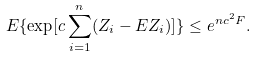Convert formula to latex. <formula><loc_0><loc_0><loc_500><loc_500>E \{ \exp [ c \sum _ { i = 1 } ^ { n } ( Z _ { i } - E Z _ { i } ) ] \} \leq e ^ { n c ^ { 2 } F } .</formula> 